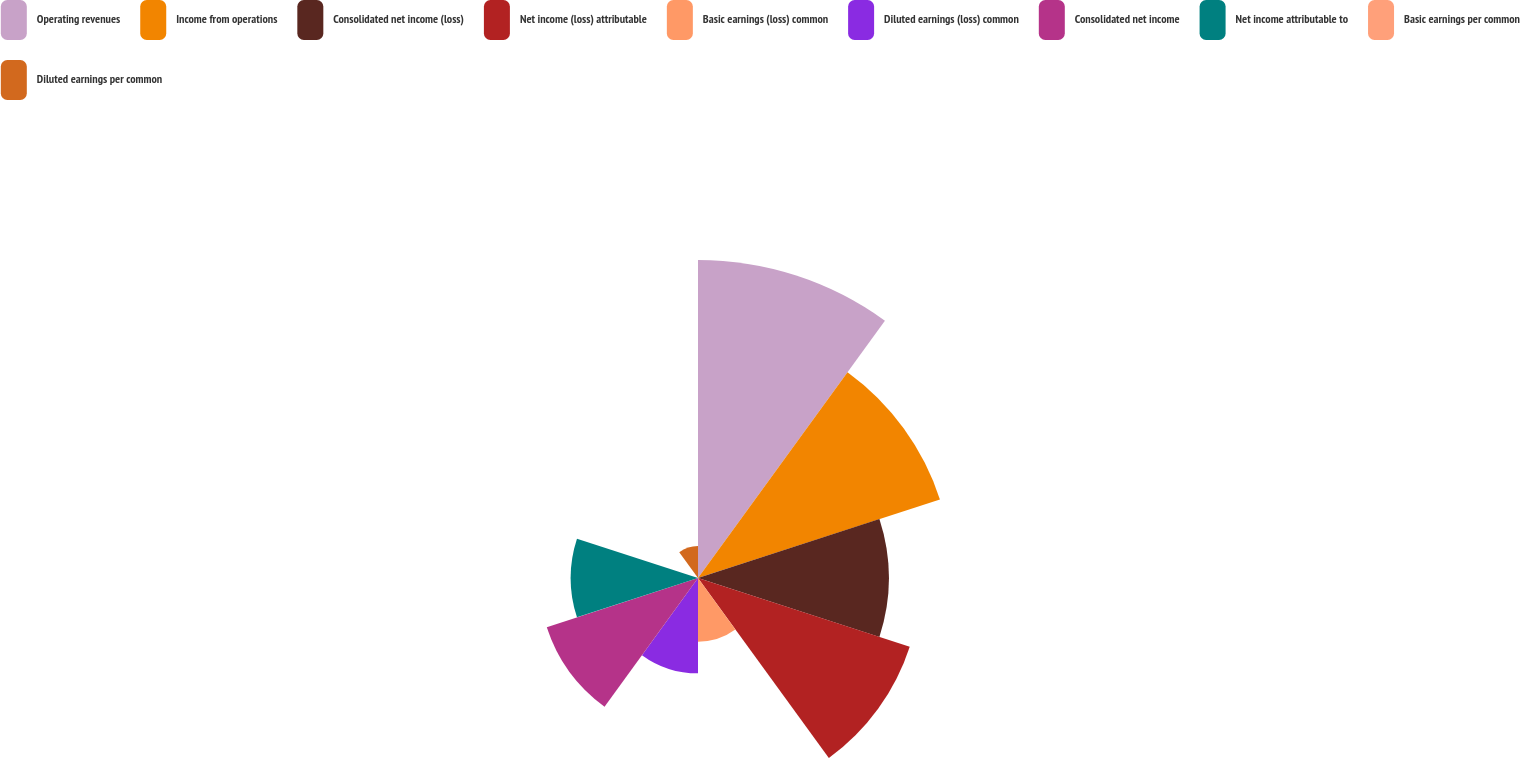Convert chart. <chart><loc_0><loc_0><loc_500><loc_500><pie_chart><fcel>Operating revenues<fcel>Income from operations<fcel>Consolidated net income (loss)<fcel>Net income (loss) attributable<fcel>Basic earnings (loss) common<fcel>Diluted earnings (loss) common<fcel>Consolidated net income<fcel>Net income attributable to<fcel>Basic earnings per common<fcel>Diluted earnings per common<nl><fcel>21.74%<fcel>17.39%<fcel>13.04%<fcel>15.22%<fcel>4.35%<fcel>6.52%<fcel>10.87%<fcel>8.7%<fcel>0.0%<fcel>2.18%<nl></chart> 